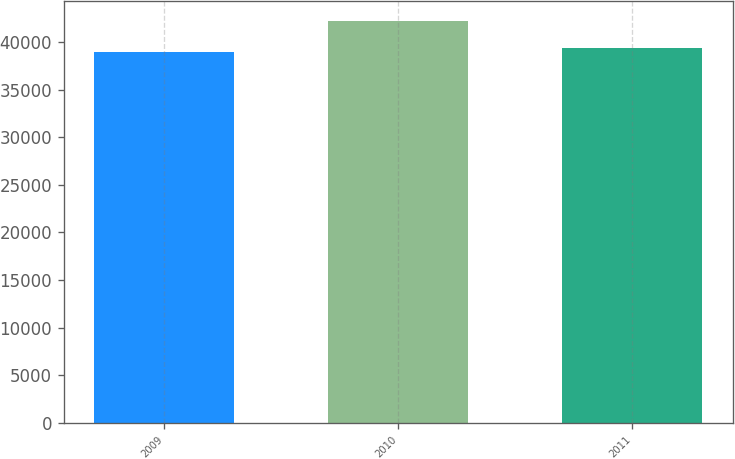Convert chart to OTSL. <chart><loc_0><loc_0><loc_500><loc_500><bar_chart><fcel>2009<fcel>2010<fcel>2011<nl><fcel>39018<fcel>42204<fcel>39343<nl></chart> 